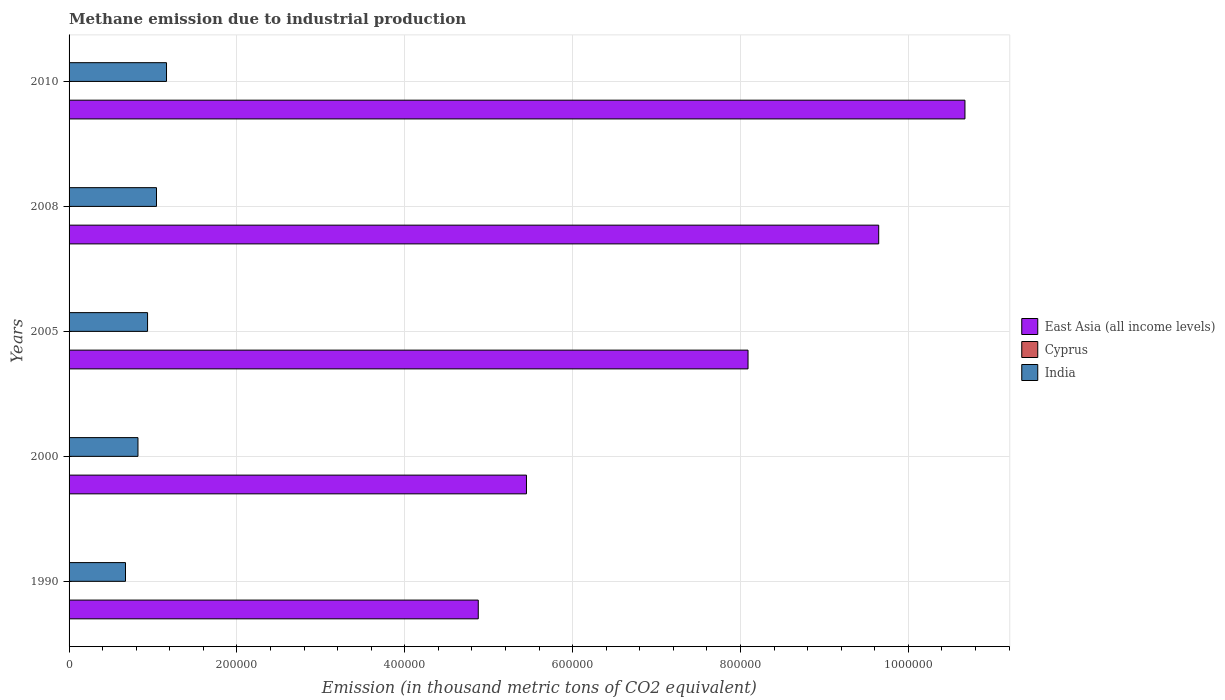How many groups of bars are there?
Offer a very short reply. 5. Are the number of bars per tick equal to the number of legend labels?
Provide a succinct answer. Yes. Are the number of bars on each tick of the Y-axis equal?
Keep it short and to the point. Yes. What is the amount of methane emitted in Cyprus in 2005?
Ensure brevity in your answer.  13.7. Across all years, what is the maximum amount of methane emitted in India?
Keep it short and to the point. 1.16e+05. Across all years, what is the minimum amount of methane emitted in India?
Keep it short and to the point. 6.72e+04. In which year was the amount of methane emitted in India maximum?
Ensure brevity in your answer.  2010. In which year was the amount of methane emitted in India minimum?
Your answer should be very brief. 1990. What is the total amount of methane emitted in India in the graph?
Offer a terse response. 4.63e+05. What is the difference between the amount of methane emitted in Cyprus in 2000 and that in 2005?
Your answer should be very brief. 8. What is the difference between the amount of methane emitted in Cyprus in 2010 and the amount of methane emitted in India in 2008?
Your answer should be very brief. -1.04e+05. What is the average amount of methane emitted in India per year?
Give a very brief answer. 9.26e+04. In the year 2010, what is the difference between the amount of methane emitted in Cyprus and amount of methane emitted in East Asia (all income levels)?
Give a very brief answer. -1.07e+06. In how many years, is the amount of methane emitted in Cyprus greater than 1000000 thousand metric tons?
Provide a succinct answer. 0. What is the ratio of the amount of methane emitted in India in 2000 to that in 2008?
Your answer should be compact. 0.79. What is the difference between the highest and the second highest amount of methane emitted in Cyprus?
Provide a succinct answer. 5.7. What is the difference between the highest and the lowest amount of methane emitted in East Asia (all income levels)?
Give a very brief answer. 5.80e+05. What does the 1st bar from the top in 1990 represents?
Offer a very short reply. India. What does the 1st bar from the bottom in 1990 represents?
Offer a very short reply. East Asia (all income levels). How many bars are there?
Offer a terse response. 15. Where does the legend appear in the graph?
Your answer should be compact. Center right. How are the legend labels stacked?
Keep it short and to the point. Vertical. What is the title of the graph?
Make the answer very short. Methane emission due to industrial production. Does "Nicaragua" appear as one of the legend labels in the graph?
Provide a short and direct response. No. What is the label or title of the X-axis?
Make the answer very short. Emission (in thousand metric tons of CO2 equivalent). What is the Emission (in thousand metric tons of CO2 equivalent) of East Asia (all income levels) in 1990?
Give a very brief answer. 4.88e+05. What is the Emission (in thousand metric tons of CO2 equivalent) of Cyprus in 1990?
Your answer should be compact. 14.7. What is the Emission (in thousand metric tons of CO2 equivalent) in India in 1990?
Ensure brevity in your answer.  6.72e+04. What is the Emission (in thousand metric tons of CO2 equivalent) of East Asia (all income levels) in 2000?
Offer a very short reply. 5.45e+05. What is the Emission (in thousand metric tons of CO2 equivalent) in Cyprus in 2000?
Your response must be concise. 21.7. What is the Emission (in thousand metric tons of CO2 equivalent) of India in 2000?
Your response must be concise. 8.21e+04. What is the Emission (in thousand metric tons of CO2 equivalent) of East Asia (all income levels) in 2005?
Your answer should be very brief. 8.09e+05. What is the Emission (in thousand metric tons of CO2 equivalent) in India in 2005?
Your answer should be compact. 9.35e+04. What is the Emission (in thousand metric tons of CO2 equivalent) of East Asia (all income levels) in 2008?
Keep it short and to the point. 9.65e+05. What is the Emission (in thousand metric tons of CO2 equivalent) in Cyprus in 2008?
Your answer should be compact. 16. What is the Emission (in thousand metric tons of CO2 equivalent) of India in 2008?
Your answer should be compact. 1.04e+05. What is the Emission (in thousand metric tons of CO2 equivalent) of East Asia (all income levels) in 2010?
Provide a succinct answer. 1.07e+06. What is the Emission (in thousand metric tons of CO2 equivalent) in India in 2010?
Give a very brief answer. 1.16e+05. Across all years, what is the maximum Emission (in thousand metric tons of CO2 equivalent) in East Asia (all income levels)?
Offer a terse response. 1.07e+06. Across all years, what is the maximum Emission (in thousand metric tons of CO2 equivalent) in Cyprus?
Your answer should be very brief. 21.7. Across all years, what is the maximum Emission (in thousand metric tons of CO2 equivalent) in India?
Your answer should be compact. 1.16e+05. Across all years, what is the minimum Emission (in thousand metric tons of CO2 equivalent) in East Asia (all income levels)?
Your response must be concise. 4.88e+05. Across all years, what is the minimum Emission (in thousand metric tons of CO2 equivalent) in Cyprus?
Your answer should be compact. 13.3. Across all years, what is the minimum Emission (in thousand metric tons of CO2 equivalent) in India?
Ensure brevity in your answer.  6.72e+04. What is the total Emission (in thousand metric tons of CO2 equivalent) of East Asia (all income levels) in the graph?
Make the answer very short. 3.87e+06. What is the total Emission (in thousand metric tons of CO2 equivalent) of Cyprus in the graph?
Provide a short and direct response. 79.4. What is the total Emission (in thousand metric tons of CO2 equivalent) of India in the graph?
Give a very brief answer. 4.63e+05. What is the difference between the Emission (in thousand metric tons of CO2 equivalent) in East Asia (all income levels) in 1990 and that in 2000?
Provide a short and direct response. -5.74e+04. What is the difference between the Emission (in thousand metric tons of CO2 equivalent) in Cyprus in 1990 and that in 2000?
Your answer should be compact. -7. What is the difference between the Emission (in thousand metric tons of CO2 equivalent) of India in 1990 and that in 2000?
Your answer should be very brief. -1.49e+04. What is the difference between the Emission (in thousand metric tons of CO2 equivalent) in East Asia (all income levels) in 1990 and that in 2005?
Your answer should be compact. -3.21e+05. What is the difference between the Emission (in thousand metric tons of CO2 equivalent) of India in 1990 and that in 2005?
Your answer should be very brief. -2.63e+04. What is the difference between the Emission (in thousand metric tons of CO2 equivalent) of East Asia (all income levels) in 1990 and that in 2008?
Offer a terse response. -4.77e+05. What is the difference between the Emission (in thousand metric tons of CO2 equivalent) in India in 1990 and that in 2008?
Provide a short and direct response. -3.69e+04. What is the difference between the Emission (in thousand metric tons of CO2 equivalent) of East Asia (all income levels) in 1990 and that in 2010?
Provide a succinct answer. -5.80e+05. What is the difference between the Emission (in thousand metric tons of CO2 equivalent) of India in 1990 and that in 2010?
Make the answer very short. -4.89e+04. What is the difference between the Emission (in thousand metric tons of CO2 equivalent) of East Asia (all income levels) in 2000 and that in 2005?
Your response must be concise. -2.64e+05. What is the difference between the Emission (in thousand metric tons of CO2 equivalent) in Cyprus in 2000 and that in 2005?
Your response must be concise. 8. What is the difference between the Emission (in thousand metric tons of CO2 equivalent) of India in 2000 and that in 2005?
Offer a terse response. -1.14e+04. What is the difference between the Emission (in thousand metric tons of CO2 equivalent) in East Asia (all income levels) in 2000 and that in 2008?
Your answer should be very brief. -4.20e+05. What is the difference between the Emission (in thousand metric tons of CO2 equivalent) of Cyprus in 2000 and that in 2008?
Your answer should be compact. 5.7. What is the difference between the Emission (in thousand metric tons of CO2 equivalent) of India in 2000 and that in 2008?
Make the answer very short. -2.21e+04. What is the difference between the Emission (in thousand metric tons of CO2 equivalent) of East Asia (all income levels) in 2000 and that in 2010?
Offer a terse response. -5.22e+05. What is the difference between the Emission (in thousand metric tons of CO2 equivalent) of Cyprus in 2000 and that in 2010?
Your response must be concise. 8.4. What is the difference between the Emission (in thousand metric tons of CO2 equivalent) in India in 2000 and that in 2010?
Ensure brevity in your answer.  -3.40e+04. What is the difference between the Emission (in thousand metric tons of CO2 equivalent) in East Asia (all income levels) in 2005 and that in 2008?
Provide a succinct answer. -1.56e+05. What is the difference between the Emission (in thousand metric tons of CO2 equivalent) in Cyprus in 2005 and that in 2008?
Provide a short and direct response. -2.3. What is the difference between the Emission (in thousand metric tons of CO2 equivalent) in India in 2005 and that in 2008?
Make the answer very short. -1.06e+04. What is the difference between the Emission (in thousand metric tons of CO2 equivalent) of East Asia (all income levels) in 2005 and that in 2010?
Provide a short and direct response. -2.58e+05. What is the difference between the Emission (in thousand metric tons of CO2 equivalent) of Cyprus in 2005 and that in 2010?
Your answer should be compact. 0.4. What is the difference between the Emission (in thousand metric tons of CO2 equivalent) of India in 2005 and that in 2010?
Offer a very short reply. -2.26e+04. What is the difference between the Emission (in thousand metric tons of CO2 equivalent) of East Asia (all income levels) in 2008 and that in 2010?
Give a very brief answer. -1.03e+05. What is the difference between the Emission (in thousand metric tons of CO2 equivalent) in India in 2008 and that in 2010?
Ensure brevity in your answer.  -1.19e+04. What is the difference between the Emission (in thousand metric tons of CO2 equivalent) of East Asia (all income levels) in 1990 and the Emission (in thousand metric tons of CO2 equivalent) of Cyprus in 2000?
Make the answer very short. 4.88e+05. What is the difference between the Emission (in thousand metric tons of CO2 equivalent) of East Asia (all income levels) in 1990 and the Emission (in thousand metric tons of CO2 equivalent) of India in 2000?
Ensure brevity in your answer.  4.05e+05. What is the difference between the Emission (in thousand metric tons of CO2 equivalent) of Cyprus in 1990 and the Emission (in thousand metric tons of CO2 equivalent) of India in 2000?
Your response must be concise. -8.21e+04. What is the difference between the Emission (in thousand metric tons of CO2 equivalent) of East Asia (all income levels) in 1990 and the Emission (in thousand metric tons of CO2 equivalent) of Cyprus in 2005?
Offer a terse response. 4.88e+05. What is the difference between the Emission (in thousand metric tons of CO2 equivalent) of East Asia (all income levels) in 1990 and the Emission (in thousand metric tons of CO2 equivalent) of India in 2005?
Your response must be concise. 3.94e+05. What is the difference between the Emission (in thousand metric tons of CO2 equivalent) in Cyprus in 1990 and the Emission (in thousand metric tons of CO2 equivalent) in India in 2005?
Your answer should be very brief. -9.35e+04. What is the difference between the Emission (in thousand metric tons of CO2 equivalent) in East Asia (all income levels) in 1990 and the Emission (in thousand metric tons of CO2 equivalent) in Cyprus in 2008?
Your answer should be compact. 4.88e+05. What is the difference between the Emission (in thousand metric tons of CO2 equivalent) in East Asia (all income levels) in 1990 and the Emission (in thousand metric tons of CO2 equivalent) in India in 2008?
Give a very brief answer. 3.83e+05. What is the difference between the Emission (in thousand metric tons of CO2 equivalent) of Cyprus in 1990 and the Emission (in thousand metric tons of CO2 equivalent) of India in 2008?
Provide a short and direct response. -1.04e+05. What is the difference between the Emission (in thousand metric tons of CO2 equivalent) of East Asia (all income levels) in 1990 and the Emission (in thousand metric tons of CO2 equivalent) of Cyprus in 2010?
Offer a very short reply. 4.88e+05. What is the difference between the Emission (in thousand metric tons of CO2 equivalent) of East Asia (all income levels) in 1990 and the Emission (in thousand metric tons of CO2 equivalent) of India in 2010?
Offer a very short reply. 3.71e+05. What is the difference between the Emission (in thousand metric tons of CO2 equivalent) of Cyprus in 1990 and the Emission (in thousand metric tons of CO2 equivalent) of India in 2010?
Your answer should be compact. -1.16e+05. What is the difference between the Emission (in thousand metric tons of CO2 equivalent) of East Asia (all income levels) in 2000 and the Emission (in thousand metric tons of CO2 equivalent) of Cyprus in 2005?
Offer a terse response. 5.45e+05. What is the difference between the Emission (in thousand metric tons of CO2 equivalent) of East Asia (all income levels) in 2000 and the Emission (in thousand metric tons of CO2 equivalent) of India in 2005?
Keep it short and to the point. 4.51e+05. What is the difference between the Emission (in thousand metric tons of CO2 equivalent) in Cyprus in 2000 and the Emission (in thousand metric tons of CO2 equivalent) in India in 2005?
Give a very brief answer. -9.35e+04. What is the difference between the Emission (in thousand metric tons of CO2 equivalent) in East Asia (all income levels) in 2000 and the Emission (in thousand metric tons of CO2 equivalent) in Cyprus in 2008?
Give a very brief answer. 5.45e+05. What is the difference between the Emission (in thousand metric tons of CO2 equivalent) of East Asia (all income levels) in 2000 and the Emission (in thousand metric tons of CO2 equivalent) of India in 2008?
Offer a terse response. 4.41e+05. What is the difference between the Emission (in thousand metric tons of CO2 equivalent) in Cyprus in 2000 and the Emission (in thousand metric tons of CO2 equivalent) in India in 2008?
Make the answer very short. -1.04e+05. What is the difference between the Emission (in thousand metric tons of CO2 equivalent) in East Asia (all income levels) in 2000 and the Emission (in thousand metric tons of CO2 equivalent) in Cyprus in 2010?
Ensure brevity in your answer.  5.45e+05. What is the difference between the Emission (in thousand metric tons of CO2 equivalent) in East Asia (all income levels) in 2000 and the Emission (in thousand metric tons of CO2 equivalent) in India in 2010?
Keep it short and to the point. 4.29e+05. What is the difference between the Emission (in thousand metric tons of CO2 equivalent) in Cyprus in 2000 and the Emission (in thousand metric tons of CO2 equivalent) in India in 2010?
Your answer should be compact. -1.16e+05. What is the difference between the Emission (in thousand metric tons of CO2 equivalent) in East Asia (all income levels) in 2005 and the Emission (in thousand metric tons of CO2 equivalent) in Cyprus in 2008?
Keep it short and to the point. 8.09e+05. What is the difference between the Emission (in thousand metric tons of CO2 equivalent) in East Asia (all income levels) in 2005 and the Emission (in thousand metric tons of CO2 equivalent) in India in 2008?
Provide a short and direct response. 7.05e+05. What is the difference between the Emission (in thousand metric tons of CO2 equivalent) in Cyprus in 2005 and the Emission (in thousand metric tons of CO2 equivalent) in India in 2008?
Offer a very short reply. -1.04e+05. What is the difference between the Emission (in thousand metric tons of CO2 equivalent) in East Asia (all income levels) in 2005 and the Emission (in thousand metric tons of CO2 equivalent) in Cyprus in 2010?
Ensure brevity in your answer.  8.09e+05. What is the difference between the Emission (in thousand metric tons of CO2 equivalent) in East Asia (all income levels) in 2005 and the Emission (in thousand metric tons of CO2 equivalent) in India in 2010?
Your answer should be compact. 6.93e+05. What is the difference between the Emission (in thousand metric tons of CO2 equivalent) in Cyprus in 2005 and the Emission (in thousand metric tons of CO2 equivalent) in India in 2010?
Offer a terse response. -1.16e+05. What is the difference between the Emission (in thousand metric tons of CO2 equivalent) of East Asia (all income levels) in 2008 and the Emission (in thousand metric tons of CO2 equivalent) of Cyprus in 2010?
Keep it short and to the point. 9.65e+05. What is the difference between the Emission (in thousand metric tons of CO2 equivalent) of East Asia (all income levels) in 2008 and the Emission (in thousand metric tons of CO2 equivalent) of India in 2010?
Keep it short and to the point. 8.49e+05. What is the difference between the Emission (in thousand metric tons of CO2 equivalent) in Cyprus in 2008 and the Emission (in thousand metric tons of CO2 equivalent) in India in 2010?
Make the answer very short. -1.16e+05. What is the average Emission (in thousand metric tons of CO2 equivalent) in East Asia (all income levels) per year?
Give a very brief answer. 7.75e+05. What is the average Emission (in thousand metric tons of CO2 equivalent) in Cyprus per year?
Offer a very short reply. 15.88. What is the average Emission (in thousand metric tons of CO2 equivalent) of India per year?
Make the answer very short. 9.26e+04. In the year 1990, what is the difference between the Emission (in thousand metric tons of CO2 equivalent) of East Asia (all income levels) and Emission (in thousand metric tons of CO2 equivalent) of Cyprus?
Provide a succinct answer. 4.88e+05. In the year 1990, what is the difference between the Emission (in thousand metric tons of CO2 equivalent) in East Asia (all income levels) and Emission (in thousand metric tons of CO2 equivalent) in India?
Give a very brief answer. 4.20e+05. In the year 1990, what is the difference between the Emission (in thousand metric tons of CO2 equivalent) of Cyprus and Emission (in thousand metric tons of CO2 equivalent) of India?
Ensure brevity in your answer.  -6.72e+04. In the year 2000, what is the difference between the Emission (in thousand metric tons of CO2 equivalent) of East Asia (all income levels) and Emission (in thousand metric tons of CO2 equivalent) of Cyprus?
Provide a short and direct response. 5.45e+05. In the year 2000, what is the difference between the Emission (in thousand metric tons of CO2 equivalent) in East Asia (all income levels) and Emission (in thousand metric tons of CO2 equivalent) in India?
Offer a terse response. 4.63e+05. In the year 2000, what is the difference between the Emission (in thousand metric tons of CO2 equivalent) in Cyprus and Emission (in thousand metric tons of CO2 equivalent) in India?
Offer a terse response. -8.21e+04. In the year 2005, what is the difference between the Emission (in thousand metric tons of CO2 equivalent) of East Asia (all income levels) and Emission (in thousand metric tons of CO2 equivalent) of Cyprus?
Your response must be concise. 8.09e+05. In the year 2005, what is the difference between the Emission (in thousand metric tons of CO2 equivalent) of East Asia (all income levels) and Emission (in thousand metric tons of CO2 equivalent) of India?
Make the answer very short. 7.15e+05. In the year 2005, what is the difference between the Emission (in thousand metric tons of CO2 equivalent) in Cyprus and Emission (in thousand metric tons of CO2 equivalent) in India?
Make the answer very short. -9.35e+04. In the year 2008, what is the difference between the Emission (in thousand metric tons of CO2 equivalent) of East Asia (all income levels) and Emission (in thousand metric tons of CO2 equivalent) of Cyprus?
Your answer should be very brief. 9.65e+05. In the year 2008, what is the difference between the Emission (in thousand metric tons of CO2 equivalent) in East Asia (all income levels) and Emission (in thousand metric tons of CO2 equivalent) in India?
Ensure brevity in your answer.  8.60e+05. In the year 2008, what is the difference between the Emission (in thousand metric tons of CO2 equivalent) of Cyprus and Emission (in thousand metric tons of CO2 equivalent) of India?
Your answer should be compact. -1.04e+05. In the year 2010, what is the difference between the Emission (in thousand metric tons of CO2 equivalent) of East Asia (all income levels) and Emission (in thousand metric tons of CO2 equivalent) of Cyprus?
Give a very brief answer. 1.07e+06. In the year 2010, what is the difference between the Emission (in thousand metric tons of CO2 equivalent) of East Asia (all income levels) and Emission (in thousand metric tons of CO2 equivalent) of India?
Provide a succinct answer. 9.51e+05. In the year 2010, what is the difference between the Emission (in thousand metric tons of CO2 equivalent) of Cyprus and Emission (in thousand metric tons of CO2 equivalent) of India?
Make the answer very short. -1.16e+05. What is the ratio of the Emission (in thousand metric tons of CO2 equivalent) in East Asia (all income levels) in 1990 to that in 2000?
Give a very brief answer. 0.89. What is the ratio of the Emission (in thousand metric tons of CO2 equivalent) of Cyprus in 1990 to that in 2000?
Your answer should be very brief. 0.68. What is the ratio of the Emission (in thousand metric tons of CO2 equivalent) of India in 1990 to that in 2000?
Provide a succinct answer. 0.82. What is the ratio of the Emission (in thousand metric tons of CO2 equivalent) of East Asia (all income levels) in 1990 to that in 2005?
Offer a very short reply. 0.6. What is the ratio of the Emission (in thousand metric tons of CO2 equivalent) of Cyprus in 1990 to that in 2005?
Your response must be concise. 1.07. What is the ratio of the Emission (in thousand metric tons of CO2 equivalent) in India in 1990 to that in 2005?
Keep it short and to the point. 0.72. What is the ratio of the Emission (in thousand metric tons of CO2 equivalent) of East Asia (all income levels) in 1990 to that in 2008?
Provide a succinct answer. 0.51. What is the ratio of the Emission (in thousand metric tons of CO2 equivalent) of Cyprus in 1990 to that in 2008?
Your response must be concise. 0.92. What is the ratio of the Emission (in thousand metric tons of CO2 equivalent) of India in 1990 to that in 2008?
Offer a very short reply. 0.65. What is the ratio of the Emission (in thousand metric tons of CO2 equivalent) of East Asia (all income levels) in 1990 to that in 2010?
Keep it short and to the point. 0.46. What is the ratio of the Emission (in thousand metric tons of CO2 equivalent) in Cyprus in 1990 to that in 2010?
Your answer should be very brief. 1.11. What is the ratio of the Emission (in thousand metric tons of CO2 equivalent) in India in 1990 to that in 2010?
Make the answer very short. 0.58. What is the ratio of the Emission (in thousand metric tons of CO2 equivalent) in East Asia (all income levels) in 2000 to that in 2005?
Make the answer very short. 0.67. What is the ratio of the Emission (in thousand metric tons of CO2 equivalent) in Cyprus in 2000 to that in 2005?
Your answer should be compact. 1.58. What is the ratio of the Emission (in thousand metric tons of CO2 equivalent) of India in 2000 to that in 2005?
Offer a terse response. 0.88. What is the ratio of the Emission (in thousand metric tons of CO2 equivalent) of East Asia (all income levels) in 2000 to that in 2008?
Provide a succinct answer. 0.56. What is the ratio of the Emission (in thousand metric tons of CO2 equivalent) of Cyprus in 2000 to that in 2008?
Offer a very short reply. 1.36. What is the ratio of the Emission (in thousand metric tons of CO2 equivalent) of India in 2000 to that in 2008?
Give a very brief answer. 0.79. What is the ratio of the Emission (in thousand metric tons of CO2 equivalent) of East Asia (all income levels) in 2000 to that in 2010?
Make the answer very short. 0.51. What is the ratio of the Emission (in thousand metric tons of CO2 equivalent) of Cyprus in 2000 to that in 2010?
Make the answer very short. 1.63. What is the ratio of the Emission (in thousand metric tons of CO2 equivalent) of India in 2000 to that in 2010?
Offer a terse response. 0.71. What is the ratio of the Emission (in thousand metric tons of CO2 equivalent) in East Asia (all income levels) in 2005 to that in 2008?
Make the answer very short. 0.84. What is the ratio of the Emission (in thousand metric tons of CO2 equivalent) in Cyprus in 2005 to that in 2008?
Your answer should be compact. 0.86. What is the ratio of the Emission (in thousand metric tons of CO2 equivalent) of India in 2005 to that in 2008?
Keep it short and to the point. 0.9. What is the ratio of the Emission (in thousand metric tons of CO2 equivalent) in East Asia (all income levels) in 2005 to that in 2010?
Provide a short and direct response. 0.76. What is the ratio of the Emission (in thousand metric tons of CO2 equivalent) of Cyprus in 2005 to that in 2010?
Your answer should be compact. 1.03. What is the ratio of the Emission (in thousand metric tons of CO2 equivalent) of India in 2005 to that in 2010?
Offer a terse response. 0.81. What is the ratio of the Emission (in thousand metric tons of CO2 equivalent) of East Asia (all income levels) in 2008 to that in 2010?
Give a very brief answer. 0.9. What is the ratio of the Emission (in thousand metric tons of CO2 equivalent) of Cyprus in 2008 to that in 2010?
Your answer should be very brief. 1.2. What is the ratio of the Emission (in thousand metric tons of CO2 equivalent) of India in 2008 to that in 2010?
Offer a very short reply. 0.9. What is the difference between the highest and the second highest Emission (in thousand metric tons of CO2 equivalent) in East Asia (all income levels)?
Keep it short and to the point. 1.03e+05. What is the difference between the highest and the second highest Emission (in thousand metric tons of CO2 equivalent) of India?
Make the answer very short. 1.19e+04. What is the difference between the highest and the lowest Emission (in thousand metric tons of CO2 equivalent) in East Asia (all income levels)?
Your answer should be compact. 5.80e+05. What is the difference between the highest and the lowest Emission (in thousand metric tons of CO2 equivalent) of India?
Provide a succinct answer. 4.89e+04. 